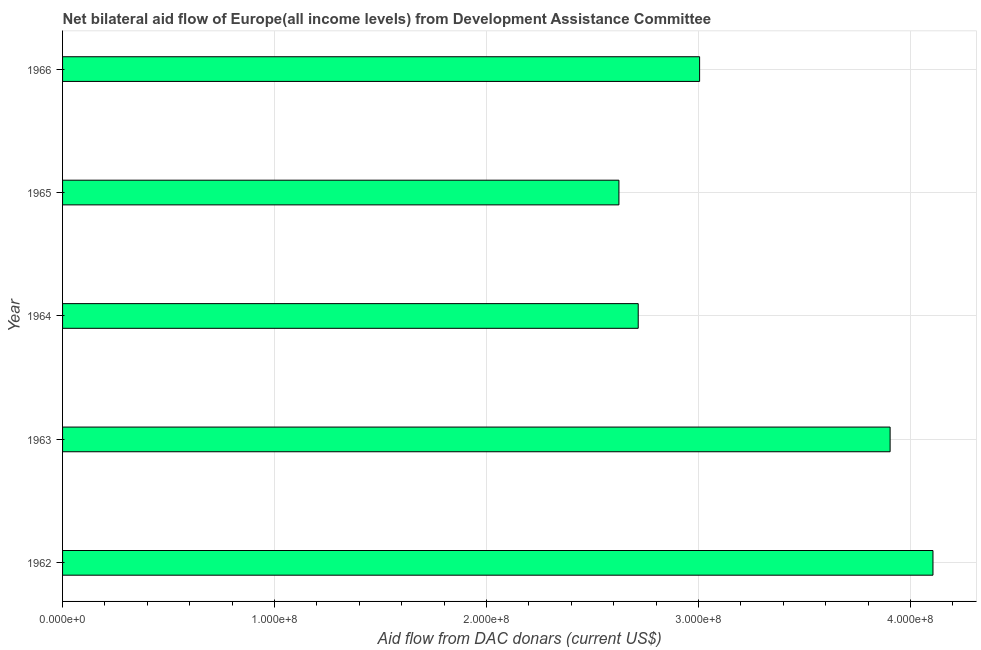Does the graph contain any zero values?
Offer a very short reply. No. Does the graph contain grids?
Ensure brevity in your answer.  Yes. What is the title of the graph?
Your answer should be very brief. Net bilateral aid flow of Europe(all income levels) from Development Assistance Committee. What is the label or title of the X-axis?
Make the answer very short. Aid flow from DAC donars (current US$). What is the label or title of the Y-axis?
Give a very brief answer. Year. What is the net bilateral aid flows from dac donors in 1963?
Your answer should be compact. 3.90e+08. Across all years, what is the maximum net bilateral aid flows from dac donors?
Provide a succinct answer. 4.11e+08. Across all years, what is the minimum net bilateral aid flows from dac donors?
Provide a short and direct response. 2.62e+08. In which year was the net bilateral aid flows from dac donors minimum?
Provide a succinct answer. 1965. What is the sum of the net bilateral aid flows from dac donors?
Your answer should be compact. 1.64e+09. What is the difference between the net bilateral aid flows from dac donors in 1964 and 1966?
Keep it short and to the point. -2.90e+07. What is the average net bilateral aid flows from dac donors per year?
Provide a succinct answer. 3.27e+08. What is the median net bilateral aid flows from dac donors?
Make the answer very short. 3.00e+08. Do a majority of the years between 1964 and 1962 (inclusive) have net bilateral aid flows from dac donors greater than 100000000 US$?
Your answer should be very brief. Yes. What is the ratio of the net bilateral aid flows from dac donors in 1965 to that in 1966?
Your answer should be compact. 0.87. Is the net bilateral aid flows from dac donors in 1963 less than that in 1965?
Ensure brevity in your answer.  No. What is the difference between the highest and the second highest net bilateral aid flows from dac donors?
Provide a short and direct response. 2.02e+07. What is the difference between the highest and the lowest net bilateral aid flows from dac donors?
Provide a succinct answer. 1.48e+08. In how many years, is the net bilateral aid flows from dac donors greater than the average net bilateral aid flows from dac donors taken over all years?
Offer a terse response. 2. Are all the bars in the graph horizontal?
Ensure brevity in your answer.  Yes. What is the Aid flow from DAC donars (current US$) in 1962?
Make the answer very short. 4.11e+08. What is the Aid flow from DAC donars (current US$) in 1963?
Give a very brief answer. 3.90e+08. What is the Aid flow from DAC donars (current US$) in 1964?
Make the answer very short. 2.72e+08. What is the Aid flow from DAC donars (current US$) of 1965?
Give a very brief answer. 2.62e+08. What is the Aid flow from DAC donars (current US$) in 1966?
Provide a short and direct response. 3.00e+08. What is the difference between the Aid flow from DAC donars (current US$) in 1962 and 1963?
Your answer should be very brief. 2.02e+07. What is the difference between the Aid flow from DAC donars (current US$) in 1962 and 1964?
Ensure brevity in your answer.  1.39e+08. What is the difference between the Aid flow from DAC donars (current US$) in 1962 and 1965?
Your answer should be compact. 1.48e+08. What is the difference between the Aid flow from DAC donars (current US$) in 1962 and 1966?
Keep it short and to the point. 1.10e+08. What is the difference between the Aid flow from DAC donars (current US$) in 1963 and 1964?
Offer a very short reply. 1.19e+08. What is the difference between the Aid flow from DAC donars (current US$) in 1963 and 1965?
Ensure brevity in your answer.  1.28e+08. What is the difference between the Aid flow from DAC donars (current US$) in 1963 and 1966?
Provide a short and direct response. 8.99e+07. What is the difference between the Aid flow from DAC donars (current US$) in 1964 and 1965?
Offer a terse response. 9.10e+06. What is the difference between the Aid flow from DAC donars (current US$) in 1964 and 1966?
Offer a very short reply. -2.90e+07. What is the difference between the Aid flow from DAC donars (current US$) in 1965 and 1966?
Your answer should be very brief. -3.81e+07. What is the ratio of the Aid flow from DAC donars (current US$) in 1962 to that in 1963?
Keep it short and to the point. 1.05. What is the ratio of the Aid flow from DAC donars (current US$) in 1962 to that in 1964?
Give a very brief answer. 1.51. What is the ratio of the Aid flow from DAC donars (current US$) in 1962 to that in 1965?
Offer a terse response. 1.56. What is the ratio of the Aid flow from DAC donars (current US$) in 1962 to that in 1966?
Offer a terse response. 1.37. What is the ratio of the Aid flow from DAC donars (current US$) in 1963 to that in 1964?
Provide a short and direct response. 1.44. What is the ratio of the Aid flow from DAC donars (current US$) in 1963 to that in 1965?
Offer a terse response. 1.49. What is the ratio of the Aid flow from DAC donars (current US$) in 1963 to that in 1966?
Provide a succinct answer. 1.3. What is the ratio of the Aid flow from DAC donars (current US$) in 1964 to that in 1965?
Offer a very short reply. 1.03. What is the ratio of the Aid flow from DAC donars (current US$) in 1964 to that in 1966?
Your answer should be compact. 0.9. What is the ratio of the Aid flow from DAC donars (current US$) in 1965 to that in 1966?
Make the answer very short. 0.87. 